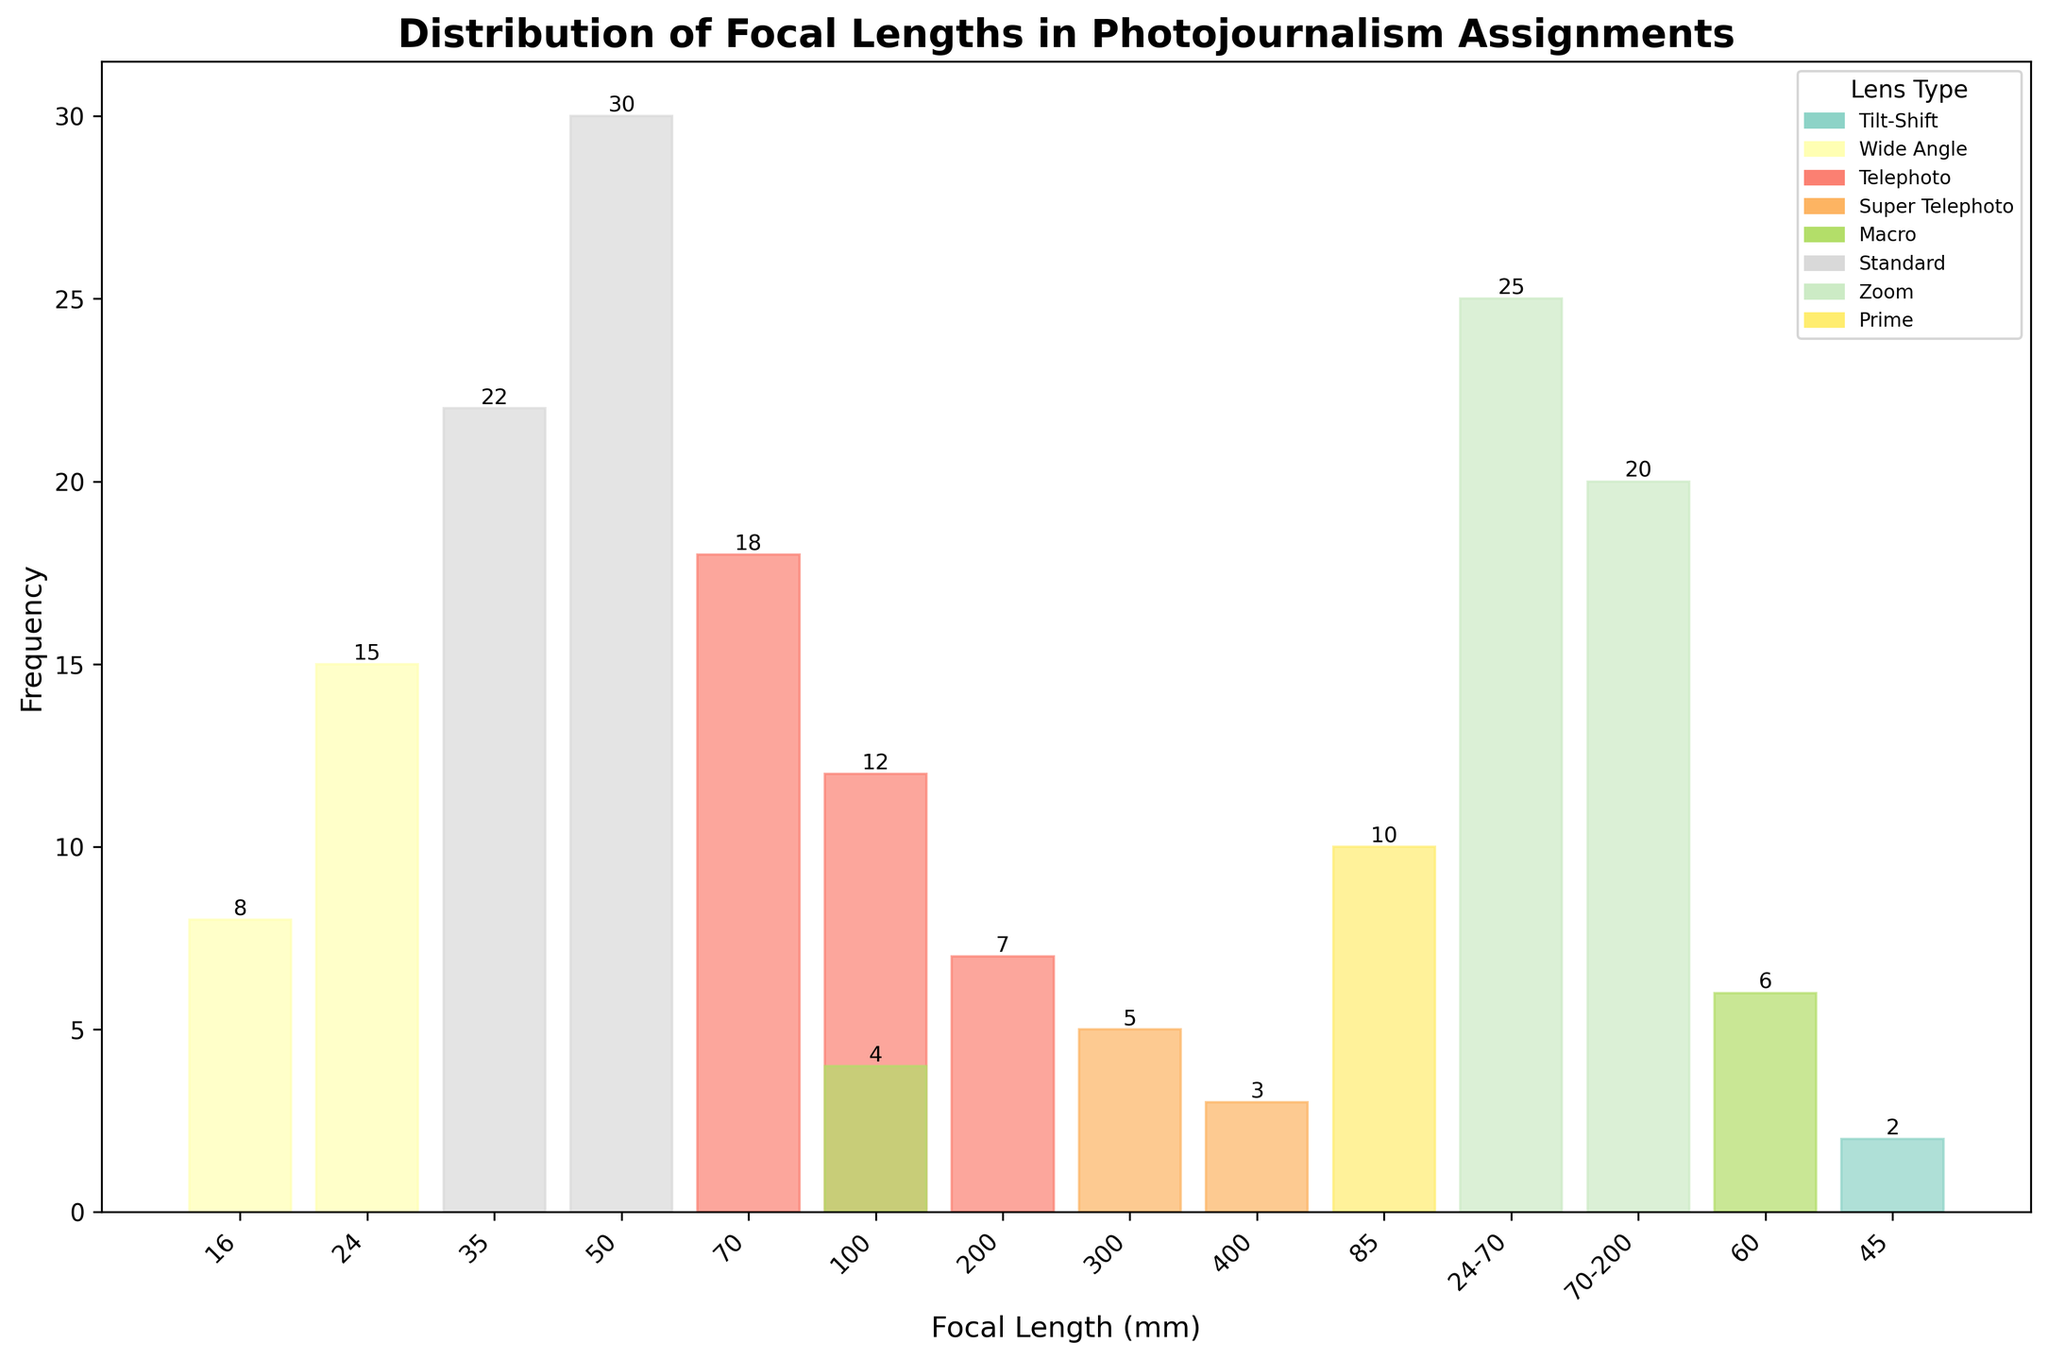What is the title of the histogram? The title of the histogram is located at the top of the figure. It is typically in larger and bold font to distinguish it from other text.
Answer: Distribution of Focal Lengths in Photojournalism Assignments How many lens types are displayed in the histogram? To determine the number of lens types, you can count the variety of colors represented in the legend since each color corresponds to a different lens type.
Answer: 8 Which focal length has the highest frequency, and what is its value? Look at the height of the bars in the histogram. The tallest bar represents the focal length with the highest frequency. Check the value label on top of this bar.
Answer: 50mm, 30 What is the sum of the frequencies for Telephoto and Super Telephoto lens types? Find the bars corresponding to Telephoto (70mm, 100mm, 200mm) and Super Telephoto (300mm, 400mm) lens types. Add the frequency values: 18 + 12 + 7 (Telephoto) + 5 + 3 (Super Telephoto) = 45.
Answer: 45 Which lens type has the least representation, and what are its frequency values? Identify the lens type with the smallest number of bars and smallest bar heights. Check the value labels on top of these bars.
Answer: Tilt-Shift, 2 What is the combined frequency of all prime lenses (Standard, Prime) used in the assignments? Identify the bars for Standard lenses (35mm, 50mm) and Prime lenses (85mm). Add their frequencies: 22 + 30 + 10 = 62.
Answer: 62 How does the frequency of the Macro 100mm lens compare to the 16mm Wide Angle lens? Find the bars for Macro 100mm and Wide Angle 16mm lenses. Compare their height and/or frequency values from the labels: 4 (Macro 100mm) and 8 (Wide Angle 16mm).
Answer: Lower Which zoom lens range has a higher frequency: 24-70mm or 70-200mm, and by how much? Look at the two bars for the zoom ranges 24-70mm and 70-200mm. Compare their frequencies from the labels on top: 25 (24-70mm) and 20 (70-200mm). Subtract the lower from the higher: 25 - 20 = 5.
Answer: 24-70mm by 5 